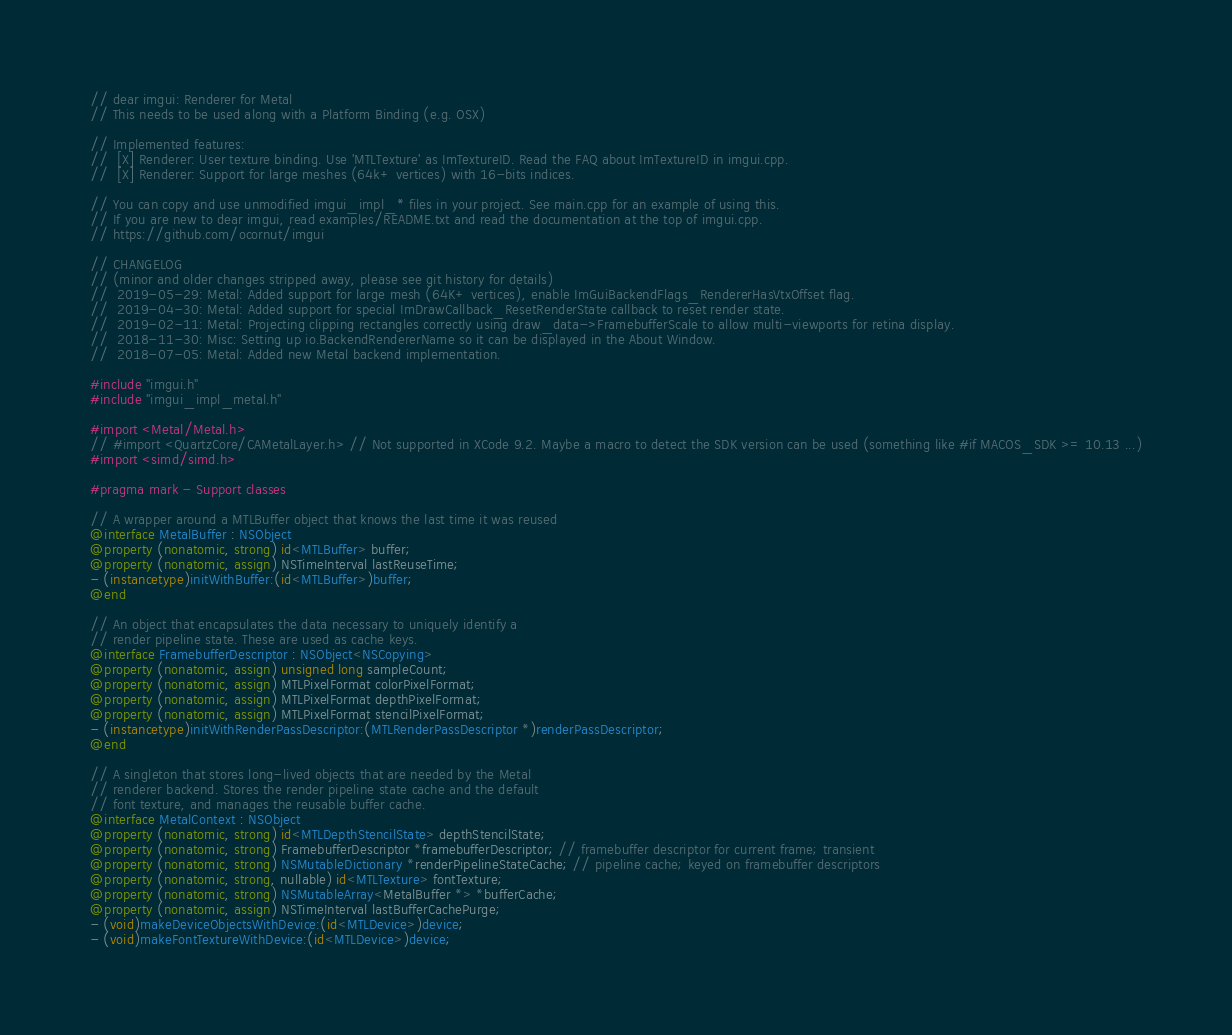Convert code to text. <code><loc_0><loc_0><loc_500><loc_500><_ObjectiveC_>// dear imgui: Renderer for Metal
// This needs to be used along with a Platform Binding (e.g. OSX)

// Implemented features:
//  [X] Renderer: User texture binding. Use 'MTLTexture' as ImTextureID. Read the FAQ about ImTextureID in imgui.cpp.
//  [X] Renderer: Support for large meshes (64k+ vertices) with 16-bits indices.

// You can copy and use unmodified imgui_impl_* files in your project. See main.cpp for an example of using this.
// If you are new to dear imgui, read examples/README.txt and read the documentation at the top of imgui.cpp.
// https://github.com/ocornut/imgui

// CHANGELOG
// (minor and older changes stripped away, please see git history for details)
//  2019-05-29: Metal: Added support for large mesh (64K+ vertices), enable ImGuiBackendFlags_RendererHasVtxOffset flag.
//  2019-04-30: Metal: Added support for special ImDrawCallback_ResetRenderState callback to reset render state.
//  2019-02-11: Metal: Projecting clipping rectangles correctly using draw_data->FramebufferScale to allow multi-viewports for retina display.
//  2018-11-30: Misc: Setting up io.BackendRendererName so it can be displayed in the About Window.
//  2018-07-05: Metal: Added new Metal backend implementation.

#include "imgui.h"
#include "imgui_impl_metal.h"

#import <Metal/Metal.h>
// #import <QuartzCore/CAMetalLayer.h> // Not supported in XCode 9.2. Maybe a macro to detect the SDK version can be used (something like #if MACOS_SDK >= 10.13 ...)
#import <simd/simd.h>

#pragma mark - Support classes

// A wrapper around a MTLBuffer object that knows the last time it was reused
@interface MetalBuffer : NSObject
@property (nonatomic, strong) id<MTLBuffer> buffer;
@property (nonatomic, assign) NSTimeInterval lastReuseTime;
- (instancetype)initWithBuffer:(id<MTLBuffer>)buffer;
@end

// An object that encapsulates the data necessary to uniquely identify a
// render pipeline state. These are used as cache keys.
@interface FramebufferDescriptor : NSObject<NSCopying>
@property (nonatomic, assign) unsigned long sampleCount;
@property (nonatomic, assign) MTLPixelFormat colorPixelFormat;
@property (nonatomic, assign) MTLPixelFormat depthPixelFormat;
@property (nonatomic, assign) MTLPixelFormat stencilPixelFormat;
- (instancetype)initWithRenderPassDescriptor:(MTLRenderPassDescriptor *)renderPassDescriptor;
@end

// A singleton that stores long-lived objects that are needed by the Metal
// renderer backend. Stores the render pipeline state cache and the default
// font texture, and manages the reusable buffer cache.
@interface MetalContext : NSObject
@property (nonatomic, strong) id<MTLDepthStencilState> depthStencilState;
@property (nonatomic, strong) FramebufferDescriptor *framebufferDescriptor; // framebuffer descriptor for current frame; transient
@property (nonatomic, strong) NSMutableDictionary *renderPipelineStateCache; // pipeline cache; keyed on framebuffer descriptors
@property (nonatomic, strong, nullable) id<MTLTexture> fontTexture;
@property (nonatomic, strong) NSMutableArray<MetalBuffer *> *bufferCache;
@property (nonatomic, assign) NSTimeInterval lastBufferCachePurge;
- (void)makeDeviceObjectsWithDevice:(id<MTLDevice>)device;
- (void)makeFontTextureWithDevice:(id<MTLDevice>)device;</code> 